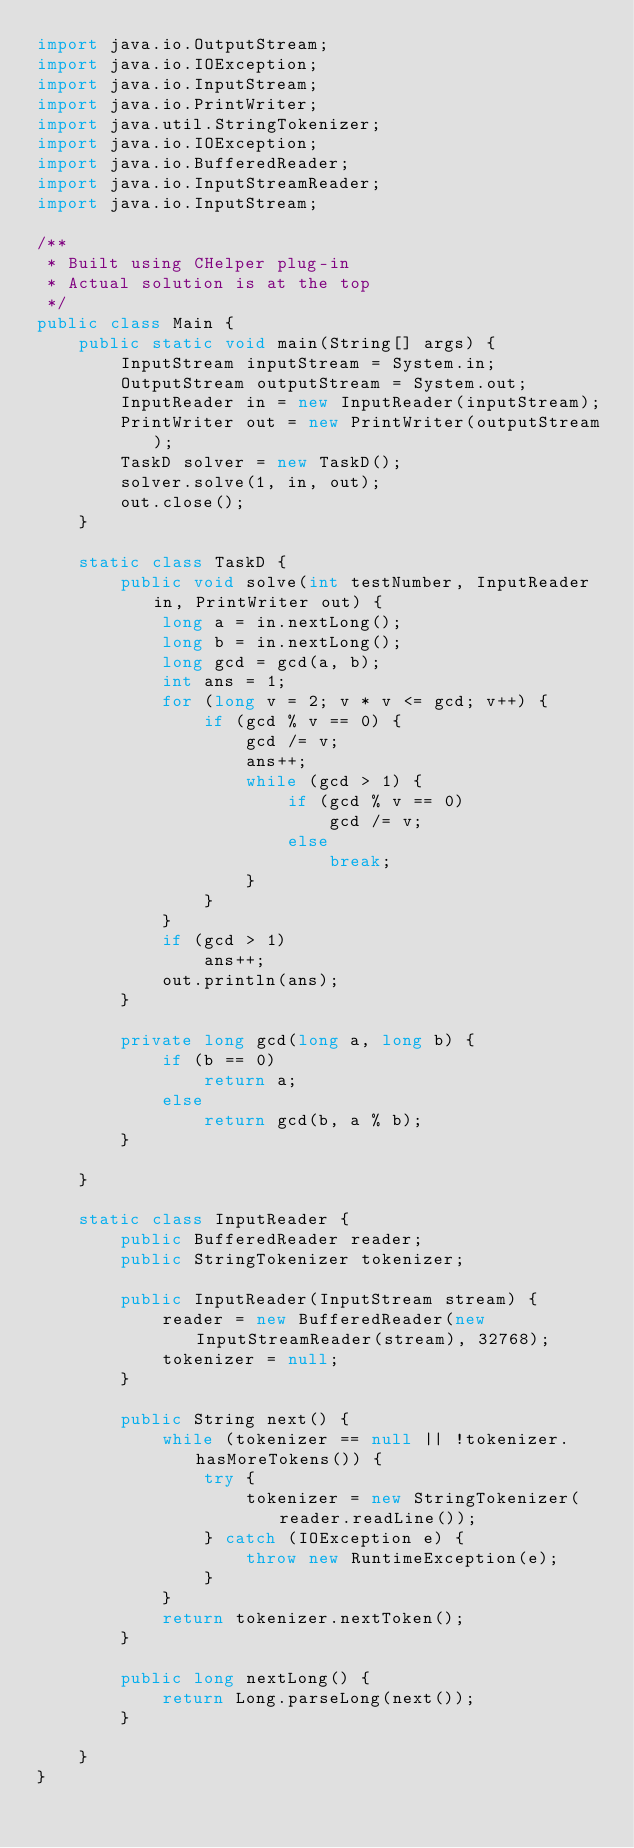Convert code to text. <code><loc_0><loc_0><loc_500><loc_500><_Java_>import java.io.OutputStream;
import java.io.IOException;
import java.io.InputStream;
import java.io.PrintWriter;
import java.util.StringTokenizer;
import java.io.IOException;
import java.io.BufferedReader;
import java.io.InputStreamReader;
import java.io.InputStream;

/**
 * Built using CHelper plug-in
 * Actual solution is at the top
 */
public class Main {
    public static void main(String[] args) {
        InputStream inputStream = System.in;
        OutputStream outputStream = System.out;
        InputReader in = new InputReader(inputStream);
        PrintWriter out = new PrintWriter(outputStream);
        TaskD solver = new TaskD();
        solver.solve(1, in, out);
        out.close();
    }

    static class TaskD {
        public void solve(int testNumber, InputReader in, PrintWriter out) {
            long a = in.nextLong();
            long b = in.nextLong();
            long gcd = gcd(a, b);
            int ans = 1;
            for (long v = 2; v * v <= gcd; v++) {
                if (gcd % v == 0) {
                    gcd /= v;
                    ans++;
                    while (gcd > 1) {
                        if (gcd % v == 0)
                            gcd /= v;
                        else
                            break;
                    }
                }
            }
            if (gcd > 1)
                ans++;
            out.println(ans);
        }

        private long gcd(long a, long b) {
            if (b == 0)
                return a;
            else
                return gcd(b, a % b);
        }

    }

    static class InputReader {
        public BufferedReader reader;
        public StringTokenizer tokenizer;

        public InputReader(InputStream stream) {
            reader = new BufferedReader(new InputStreamReader(stream), 32768);
            tokenizer = null;
        }

        public String next() {
            while (tokenizer == null || !tokenizer.hasMoreTokens()) {
                try {
                    tokenizer = new StringTokenizer(reader.readLine());
                } catch (IOException e) {
                    throw new RuntimeException(e);
                }
            }
            return tokenizer.nextToken();
        }

        public long nextLong() {
            return Long.parseLong(next());
        }

    }
}</code> 